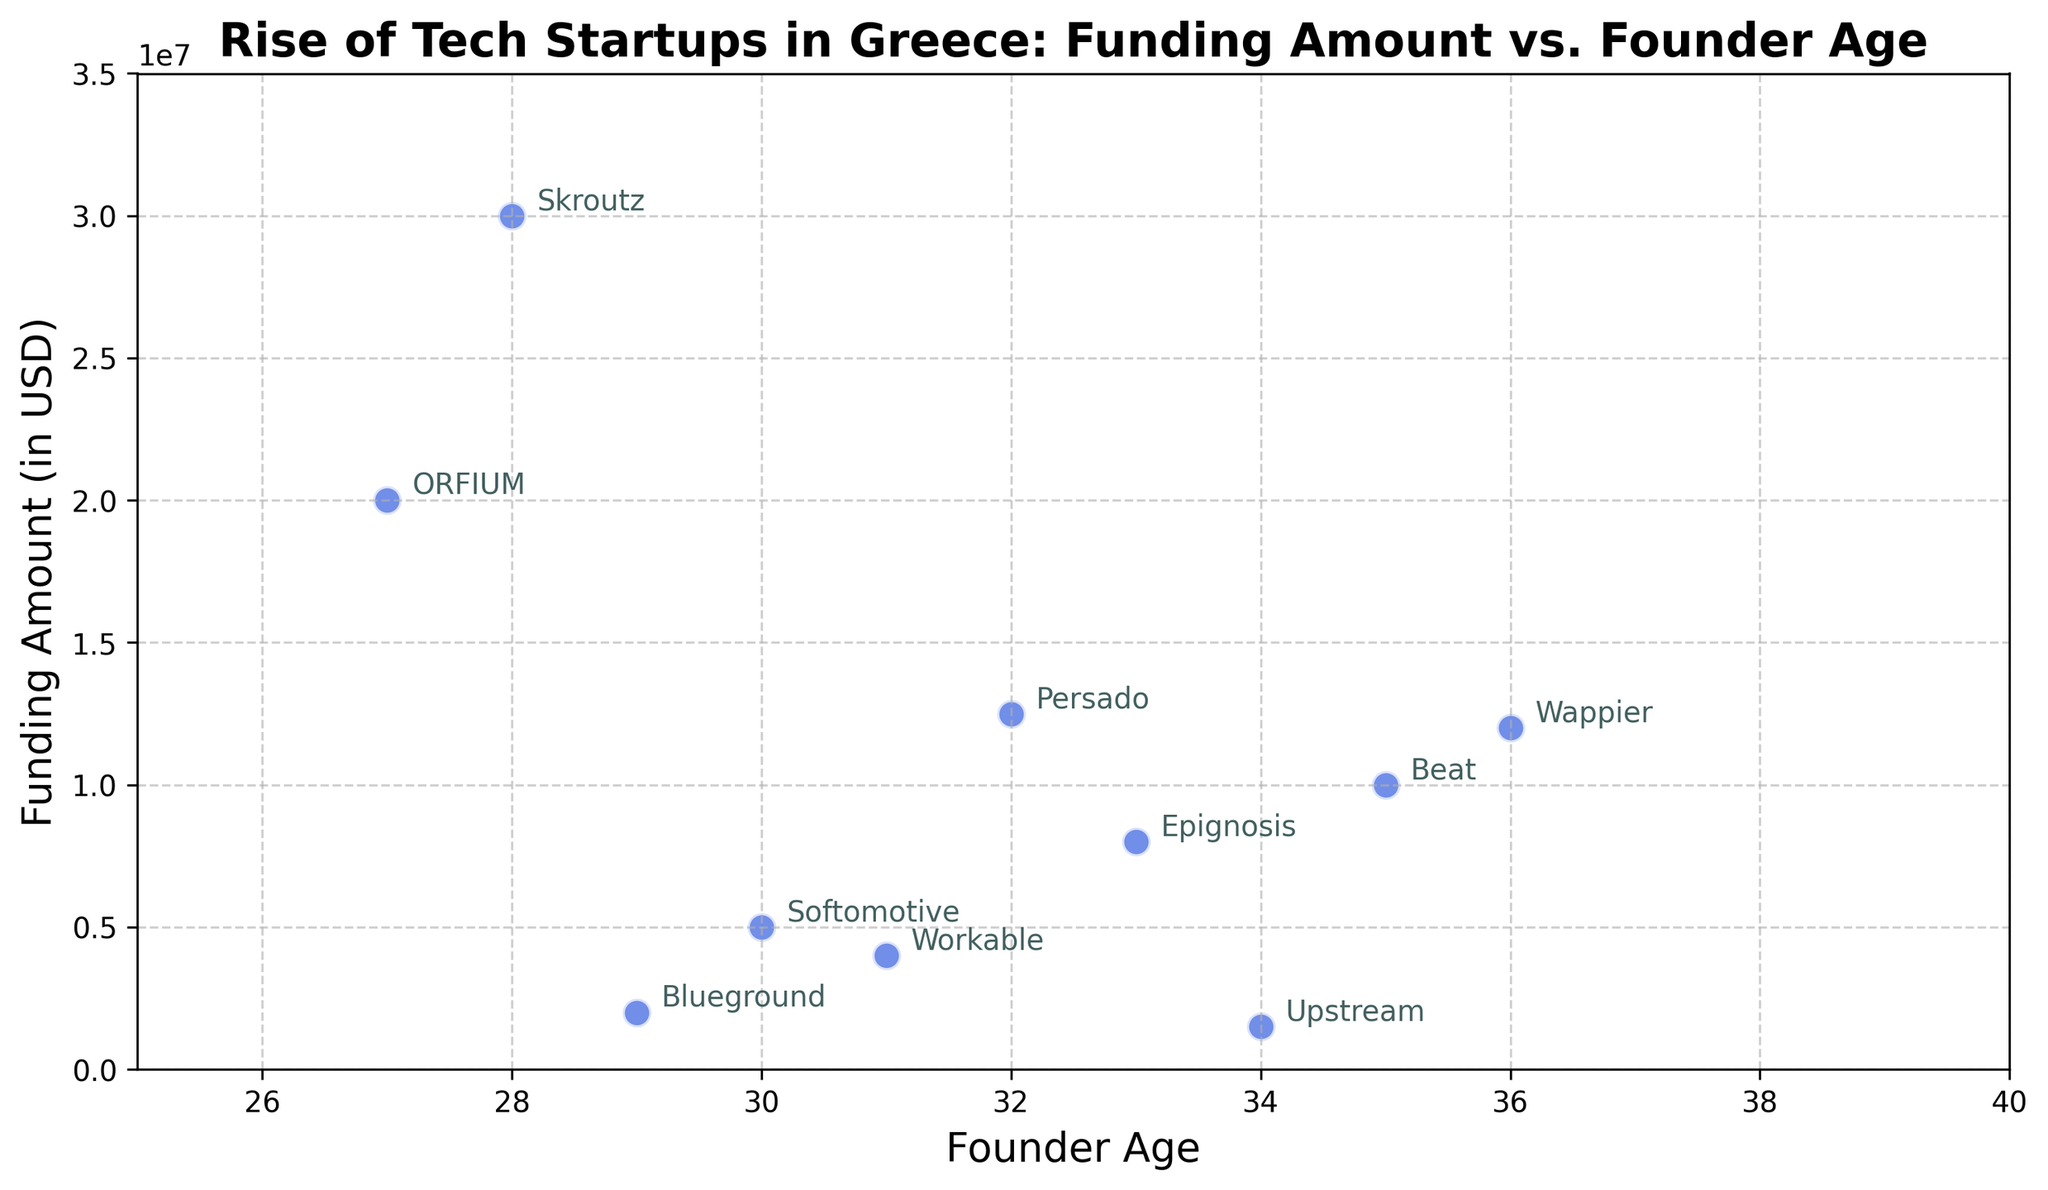What's the average age of founders who have raised more than $10,000,000? First, identify the founders who have raised more than $10,000,000. These are Beat (35), Persado (32), Skroutz (28), and ORFIUM (27). Next, sum their ages: 35 + 32 + 28 + 27 = 122. Finally, divide by the number of founders (4). Average age is 122/4 = 30.5
Answer: 30.5 Which startup received the highest funding? The plot shows funding amounts on the Y-axis, and ordered from the lowest to the highest, the highest point on the Y-axis represents Skroutz with $30,000,000.
Answer: Skroutz What is the difference in funding amounts between the oldest and youngest founder? Identify the oldest founder (Wappier, 36) and the youngest founder (ORFIUM, 27). The funding amounts are $12,000,000 (Wappier) and $20,000,000 (ORFIUM). The difference is $20,000,000 - $12,000,000 = $8,000,000.
Answer: $8,000,000 How many startups are founded by individuals aged 30 or younger? Check the ages listed on the X-axis. Startups with founders aged 30 or younger include Blueground (29), Softomotive (30), Skroutz (28), and ORFIUM (27). Count these startups: There are 4.
Answer: 4 Which two startups have founders with the closest ages? Look for ages that are almost the same on the X-axis. Workable (31) and Softomotive (30) are the closest with only a 1-year difference in founders' ages.
Answer: Workable and Softomotive What's the median funding amount for startups with founders under 35? Identify the funding amounts for founders under 35: Blueground ($2,000,000), Workable ($4,000,000), Softomotive ($5,000,000), Persado ($12,500,000), Skroutz ($30,000,000), Upstream ($1,500,000), Epignosis ($8,000,000), ORFIUM ($20,000,000). Order them: 1.5M, 2M, 4M, 5M, 8M, 12.5M, 20M, 30M. Median is the average of the 4th and 5th values: ($5,000,000 + $8,000,000)/2 = $6,500,000.
Answer: $6,500,000 What is the overall trend of funding amount with respect to founder age? Observing the scatter points, there's no consistent trend: low and high amounts are spread across different ages, implying that funding does not depend heavily on founder age.
Answer: No consistent trend Which startup with a founder age of 30 or younger received the least funding? Filter startups by founder age of 30 or younger: Blueground ($2,000,000), Softomotive ($5,000,000), Skroutz ($30,000,000), ORFIUM ($20,000,000). The least funding among them is Blueground with $2,000,000.
Answer: Blueground 